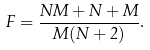Convert formula to latex. <formula><loc_0><loc_0><loc_500><loc_500>F = \frac { N M + N + M } { M ( N + 2 ) } .</formula> 